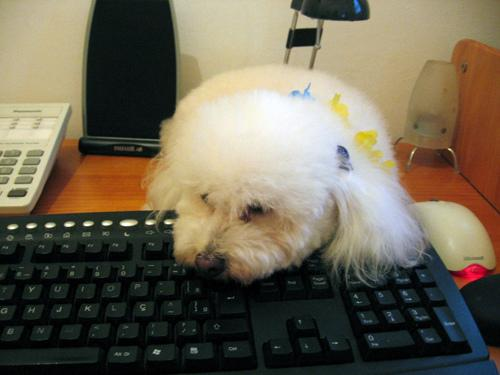Mention the design or pattern present on part of the brown table. There is a wooden pattern visible on the surface of the brown desk. Identify the type of table and one item placed on it. The image features a wooden desk with a black standard keyboard on it. Describe an interaction between the dog and a specific part of the keyboard. The dog's black nose is touching the silver buttons on the black keyboard. Mention what type of dog is present in the image and how it is interacting with any object. A small poodle dog is resting on a keyboard with its white fluffy head partially covering the keys. Briefly describe the computer mouse and its features. It is a white Microsoft optical mouse with a red light on it. Specify the type and manufacturer of the computer speaker visible in the image. The computer speaker is black and manufactured by Panasonic. Mention the colors and patterns present in the dog's collar. The dog is wearing a collar with blue and yellow flowers on it. Describe the electronics found on the desk in this image. There are a white computer mouse, black keyboard, black computer speakers, and an old beige landline telephone on the desk. Name the types of keys on the keyboard that are being mentioned in the image. The keyboard has silver buttons, number pad keys, and directional arrow keys. Point out one accessory the dog is wearing and an accessory on the desk. The dog is wearing a purple bow on its ear, and there is a clear frosted table lamp on the desk. 